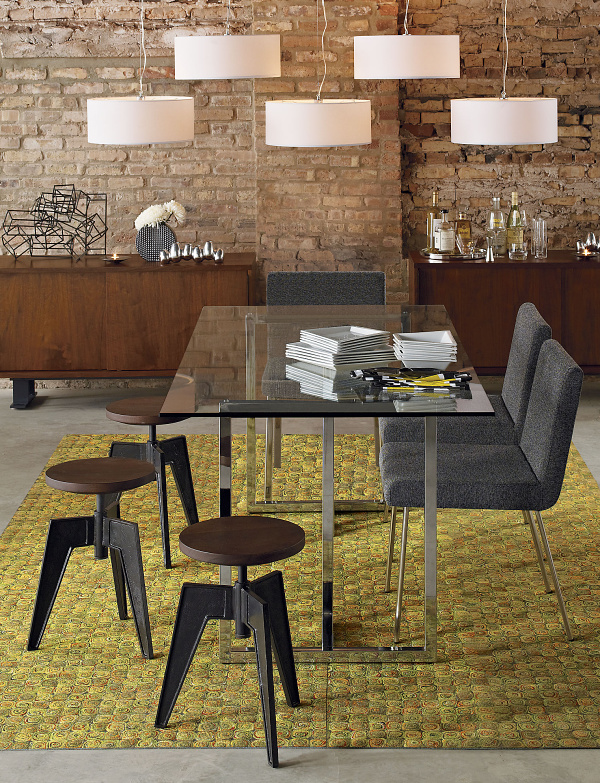What items are placed on the dining table and sideboard? On the transparent dining table, there appears to be a neatly stacked assortment of magazines or menus, accompanied by a pen, signaling perhaps an area for reading or planning. Over on the wooden sideboard, there is a curated display of various items: a vase with decorative flowers, a collection of bottles that seem to be spirits or oils, and glassware, suggesting that the space might be used for hosting and entertaining guests. 